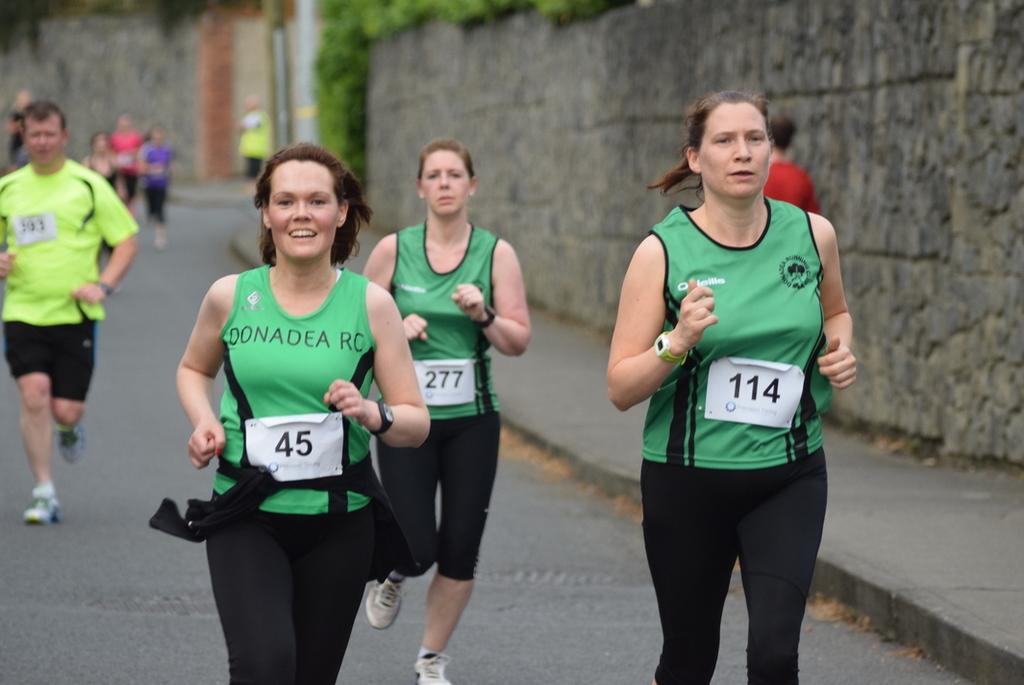What are the runners' numbers?
Your answer should be compact. 45, 277, 114. What name does the green shirt on the left say?
Offer a terse response. Donadea rc. 